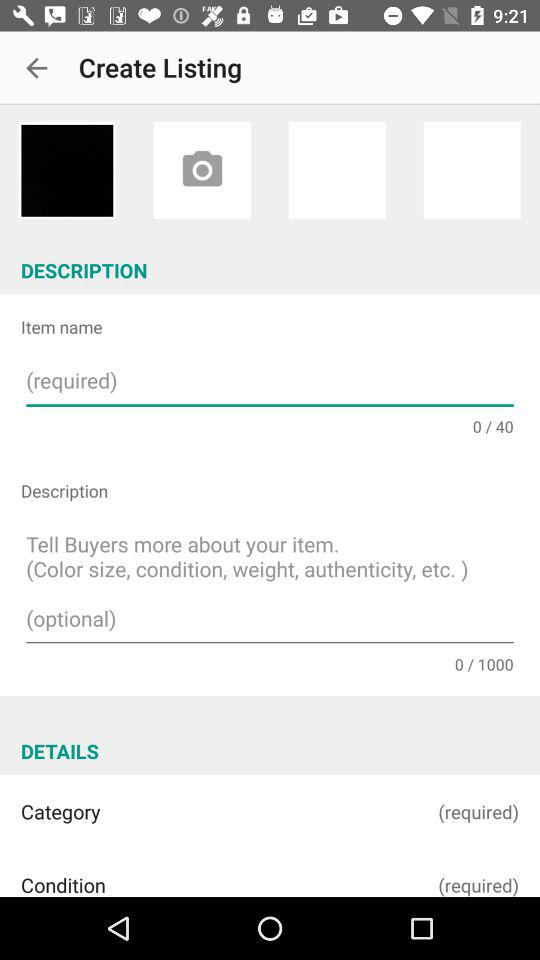How many text inputs are required in the description section?
Answer the question using a single word or phrase. 2 